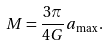Convert formula to latex. <formula><loc_0><loc_0><loc_500><loc_500>M = \frac { 3 \pi } { 4 G } a _ { \mathrm \max } \, .</formula> 